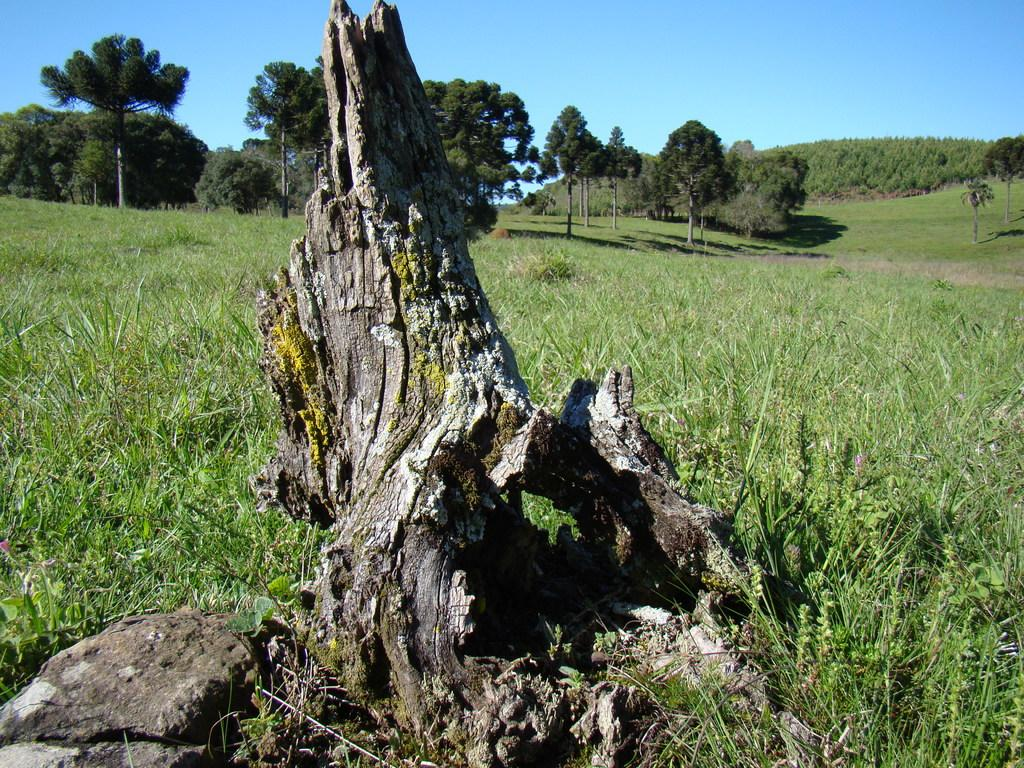What is the main object in the image? There is a piece of wood in the image. What type of ground is visible in the image? There is grass on the ground in the image. What can be seen in the background of the image? There are trees and the sky visible in the background of the image. What type of instrument is being played in the image? There is no instrument present in the image; it features a piece of wood, grass, trees, and the sky. Can you recite the verse that is written on the piece of wood in the image? There is no verse written on the piece of wood in the image; it is a plain piece of wood. 